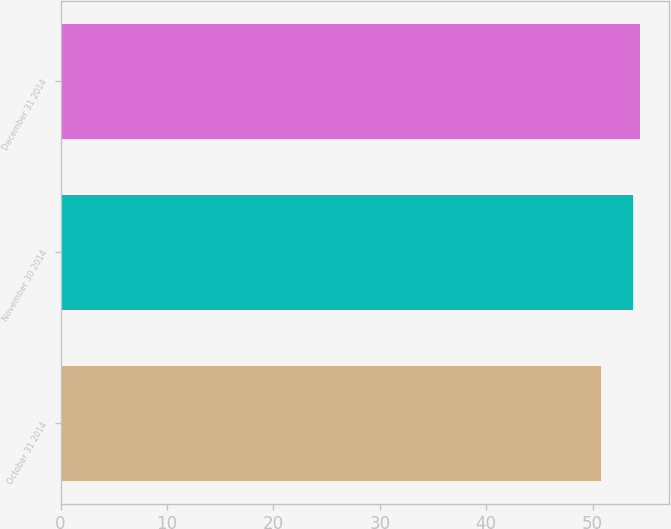Convert chart to OTSL. <chart><loc_0><loc_0><loc_500><loc_500><bar_chart><fcel>October 31 2014<fcel>November 30 2014<fcel>December 31 2014<nl><fcel>50.76<fcel>53.76<fcel>54.48<nl></chart> 